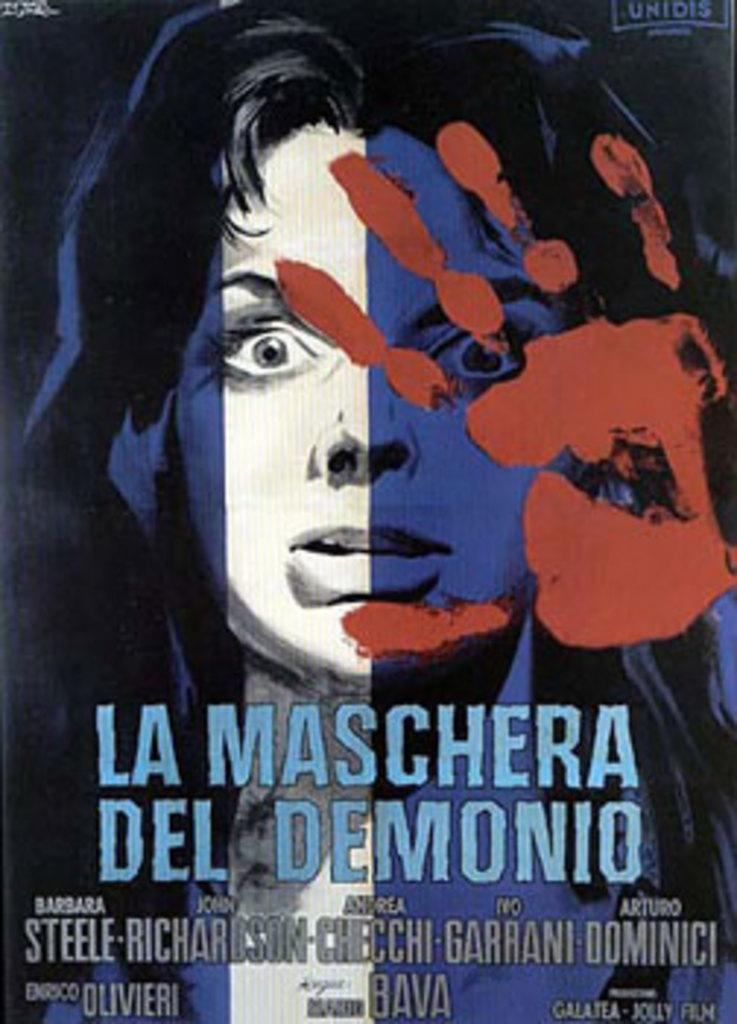What is featured on the poster in the image? The poster contains a woman's face. Are there any additional elements on the poster besides the woman's face? Yes, there is a hand print on the poster. Is there any text on the poster? Yes, there is text on the poster. What type of insurance is being advertised on the poster? There is no mention of insurance on the poster, as it features a woman's face, a hand print, and text. What kind of test is being conducted in the image? There is no test being conducted in the image; it only shows a poster with a woman's face, a hand print, and text. 